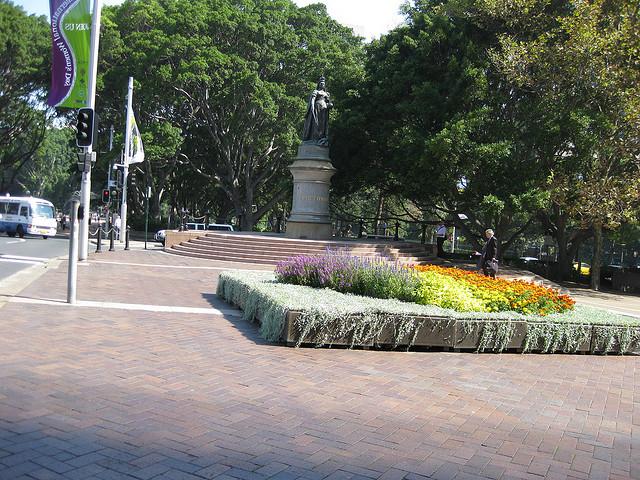Are those small trees?
Give a very brief answer. No. Is there anyone in the photo?
Write a very short answer. Yes. Are there flowers in the photo?
Be succinct. Yes. 